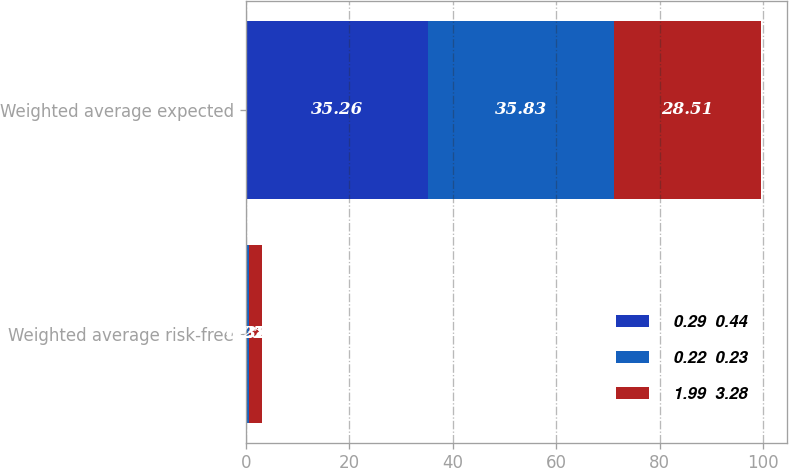Convert chart. <chart><loc_0><loc_0><loc_500><loc_500><stacked_bar_chart><ecel><fcel>Weighted average risk-free<fcel>Weighted average expected<nl><fcel>0.29  0.44<fcel>0.22<fcel>35.26<nl><fcel>0.22  0.23<fcel>0.38<fcel>35.83<nl><fcel>1.99  3.28<fcel>2.58<fcel>28.51<nl></chart> 